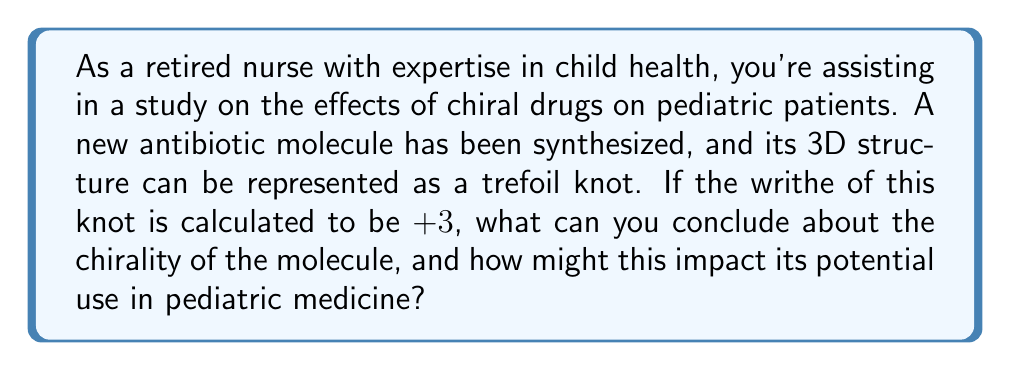What is the answer to this math problem? To understand the chirality of this pharmaceutical molecule using knot theory, let's break down the problem step-by-step:

1. Knot representation: The molecule's 3D structure is represented as a trefoil knot. Trefoil knots are the simplest non-trivial knots and can exist in two mirror-image forms.

2. Writhe calculation: The writhe of a knot is a measure of its three-dimensional writhing. It's calculated as the sum of the signs of crossings in a knot diagram. In this case, the writhe is given as +3.

3. Chirality determination:
   - A key property of the writhe is that it changes sign under mirror reflection.
   - For a trefoil knot, a positive writhe (+3) indicates a right-handed trefoil, while a negative writhe (-3) would indicate a left-handed trefoil.
   - The non-zero writhe confirms that this trefoil knot is chiral (not superimposable on its mirror image).

4. Mathematical representation:
   Let $W(K)$ represent the writhe of knot $K$.
   If $K'$ is the mirror image of $K$, then:
   $$W(K') = -W(K)$$

5. Implications for pediatric medicine:
   - Chiral molecules can have different biological activities depending on their handedness.
   - The right-handed nature of this antibiotic may affect its interaction with target bacteria or human cells.
   - It's crucial to study both enantiomers (mirror images) of chiral drugs, as they may have different efficacies or side effects in children.

6. Conclusion:
   The positive writhe (+3) indicates a right-handed chiral molecule, which may have specific implications for its effectiveness and safety in pediatric patients.
Answer: Right-handed chiral molecule 